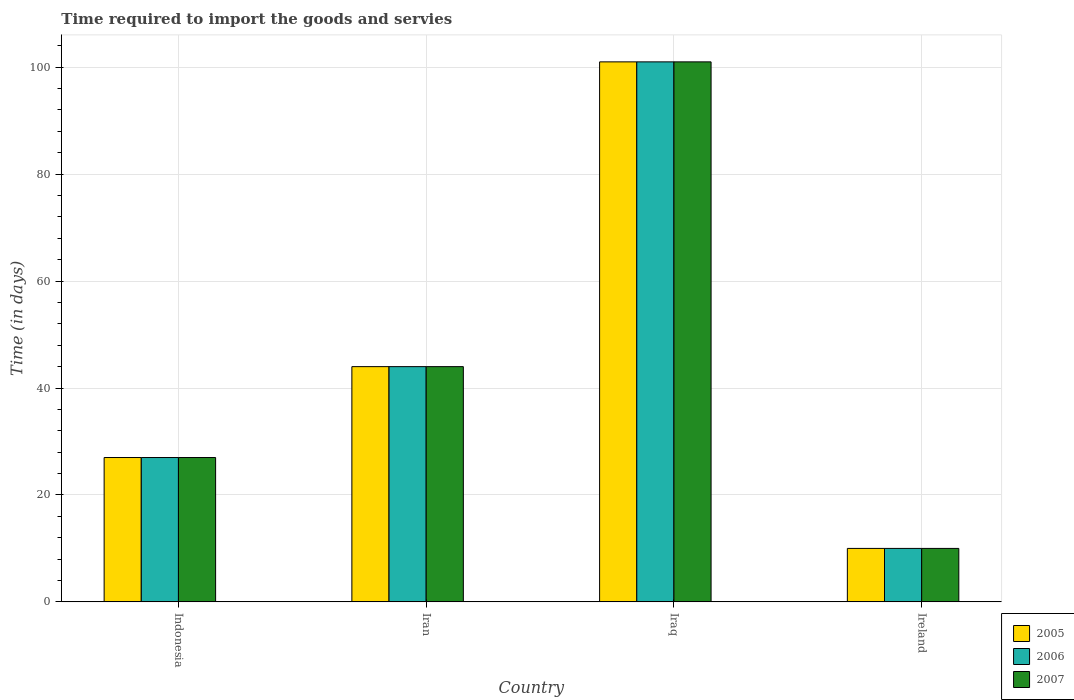How many different coloured bars are there?
Offer a terse response. 3. Are the number of bars per tick equal to the number of legend labels?
Keep it short and to the point. Yes. Are the number of bars on each tick of the X-axis equal?
Give a very brief answer. Yes. How many bars are there on the 3rd tick from the left?
Ensure brevity in your answer.  3. How many bars are there on the 4th tick from the right?
Provide a short and direct response. 3. What is the label of the 4th group of bars from the left?
Ensure brevity in your answer.  Ireland. What is the number of days required to import the goods and services in 2006 in Indonesia?
Your answer should be compact. 27. Across all countries, what is the maximum number of days required to import the goods and services in 2005?
Keep it short and to the point. 101. Across all countries, what is the minimum number of days required to import the goods and services in 2007?
Keep it short and to the point. 10. In which country was the number of days required to import the goods and services in 2006 maximum?
Provide a short and direct response. Iraq. In which country was the number of days required to import the goods and services in 2005 minimum?
Provide a short and direct response. Ireland. What is the total number of days required to import the goods and services in 2007 in the graph?
Your answer should be compact. 182. What is the difference between the number of days required to import the goods and services in 2005 in Iran and that in Iraq?
Make the answer very short. -57. What is the difference between the number of days required to import the goods and services in 2005 in Ireland and the number of days required to import the goods and services in 2006 in Iran?
Provide a succinct answer. -34. What is the average number of days required to import the goods and services in 2006 per country?
Provide a short and direct response. 45.5. Is the number of days required to import the goods and services in 2007 in Iraq less than that in Ireland?
Your response must be concise. No. What is the difference between the highest and the lowest number of days required to import the goods and services in 2005?
Your answer should be compact. 91. In how many countries, is the number of days required to import the goods and services in 2005 greater than the average number of days required to import the goods and services in 2005 taken over all countries?
Make the answer very short. 1. What does the 1st bar from the left in Iran represents?
Your response must be concise. 2005. What does the 2nd bar from the right in Iraq represents?
Offer a terse response. 2006. How many bars are there?
Provide a succinct answer. 12. Are all the bars in the graph horizontal?
Keep it short and to the point. No. How many countries are there in the graph?
Your response must be concise. 4. What is the difference between two consecutive major ticks on the Y-axis?
Your answer should be very brief. 20. Are the values on the major ticks of Y-axis written in scientific E-notation?
Keep it short and to the point. No. Does the graph contain any zero values?
Ensure brevity in your answer.  No. Where does the legend appear in the graph?
Ensure brevity in your answer.  Bottom right. How many legend labels are there?
Provide a succinct answer. 3. How are the legend labels stacked?
Make the answer very short. Vertical. What is the title of the graph?
Provide a succinct answer. Time required to import the goods and servies. What is the label or title of the Y-axis?
Your response must be concise. Time (in days). What is the Time (in days) of 2007 in Indonesia?
Your response must be concise. 27. What is the Time (in days) in 2007 in Iran?
Ensure brevity in your answer.  44. What is the Time (in days) of 2005 in Iraq?
Offer a very short reply. 101. What is the Time (in days) of 2006 in Iraq?
Your answer should be compact. 101. What is the Time (in days) in 2007 in Iraq?
Your answer should be very brief. 101. What is the Time (in days) in 2006 in Ireland?
Your answer should be compact. 10. Across all countries, what is the maximum Time (in days) of 2005?
Offer a terse response. 101. Across all countries, what is the maximum Time (in days) of 2006?
Provide a short and direct response. 101. Across all countries, what is the maximum Time (in days) in 2007?
Give a very brief answer. 101. Across all countries, what is the minimum Time (in days) of 2006?
Ensure brevity in your answer.  10. What is the total Time (in days) in 2005 in the graph?
Provide a short and direct response. 182. What is the total Time (in days) in 2006 in the graph?
Offer a very short reply. 182. What is the total Time (in days) of 2007 in the graph?
Offer a terse response. 182. What is the difference between the Time (in days) of 2006 in Indonesia and that in Iran?
Your answer should be very brief. -17. What is the difference between the Time (in days) in 2005 in Indonesia and that in Iraq?
Make the answer very short. -74. What is the difference between the Time (in days) of 2006 in Indonesia and that in Iraq?
Provide a short and direct response. -74. What is the difference between the Time (in days) in 2007 in Indonesia and that in Iraq?
Your response must be concise. -74. What is the difference between the Time (in days) of 2006 in Indonesia and that in Ireland?
Provide a short and direct response. 17. What is the difference between the Time (in days) in 2007 in Indonesia and that in Ireland?
Provide a short and direct response. 17. What is the difference between the Time (in days) in 2005 in Iran and that in Iraq?
Your answer should be very brief. -57. What is the difference between the Time (in days) in 2006 in Iran and that in Iraq?
Offer a terse response. -57. What is the difference between the Time (in days) in 2007 in Iran and that in Iraq?
Give a very brief answer. -57. What is the difference between the Time (in days) of 2005 in Iraq and that in Ireland?
Ensure brevity in your answer.  91. What is the difference between the Time (in days) in 2006 in Iraq and that in Ireland?
Provide a short and direct response. 91. What is the difference between the Time (in days) in 2007 in Iraq and that in Ireland?
Provide a short and direct response. 91. What is the difference between the Time (in days) of 2005 in Indonesia and the Time (in days) of 2006 in Iran?
Provide a short and direct response. -17. What is the difference between the Time (in days) in 2005 in Indonesia and the Time (in days) in 2006 in Iraq?
Your answer should be very brief. -74. What is the difference between the Time (in days) in 2005 in Indonesia and the Time (in days) in 2007 in Iraq?
Offer a terse response. -74. What is the difference between the Time (in days) in 2006 in Indonesia and the Time (in days) in 2007 in Iraq?
Make the answer very short. -74. What is the difference between the Time (in days) in 2006 in Indonesia and the Time (in days) in 2007 in Ireland?
Keep it short and to the point. 17. What is the difference between the Time (in days) of 2005 in Iran and the Time (in days) of 2006 in Iraq?
Provide a succinct answer. -57. What is the difference between the Time (in days) of 2005 in Iran and the Time (in days) of 2007 in Iraq?
Offer a terse response. -57. What is the difference between the Time (in days) in 2006 in Iran and the Time (in days) in 2007 in Iraq?
Offer a very short reply. -57. What is the difference between the Time (in days) in 2005 in Iran and the Time (in days) in 2007 in Ireland?
Make the answer very short. 34. What is the difference between the Time (in days) in 2005 in Iraq and the Time (in days) in 2006 in Ireland?
Ensure brevity in your answer.  91. What is the difference between the Time (in days) of 2005 in Iraq and the Time (in days) of 2007 in Ireland?
Make the answer very short. 91. What is the difference between the Time (in days) of 2006 in Iraq and the Time (in days) of 2007 in Ireland?
Ensure brevity in your answer.  91. What is the average Time (in days) of 2005 per country?
Provide a short and direct response. 45.5. What is the average Time (in days) of 2006 per country?
Your answer should be very brief. 45.5. What is the average Time (in days) in 2007 per country?
Give a very brief answer. 45.5. What is the difference between the Time (in days) in 2005 and Time (in days) in 2006 in Indonesia?
Your answer should be very brief. 0. What is the difference between the Time (in days) of 2005 and Time (in days) of 2007 in Indonesia?
Give a very brief answer. 0. What is the difference between the Time (in days) of 2005 and Time (in days) of 2007 in Iran?
Keep it short and to the point. 0. What is the difference between the Time (in days) of 2006 and Time (in days) of 2007 in Iran?
Provide a short and direct response. 0. What is the difference between the Time (in days) in 2005 and Time (in days) in 2006 in Iraq?
Give a very brief answer. 0. What is the ratio of the Time (in days) in 2005 in Indonesia to that in Iran?
Provide a short and direct response. 0.61. What is the ratio of the Time (in days) of 2006 in Indonesia to that in Iran?
Provide a short and direct response. 0.61. What is the ratio of the Time (in days) of 2007 in Indonesia to that in Iran?
Provide a succinct answer. 0.61. What is the ratio of the Time (in days) in 2005 in Indonesia to that in Iraq?
Keep it short and to the point. 0.27. What is the ratio of the Time (in days) of 2006 in Indonesia to that in Iraq?
Your answer should be very brief. 0.27. What is the ratio of the Time (in days) in 2007 in Indonesia to that in Iraq?
Ensure brevity in your answer.  0.27. What is the ratio of the Time (in days) of 2005 in Indonesia to that in Ireland?
Your response must be concise. 2.7. What is the ratio of the Time (in days) of 2005 in Iran to that in Iraq?
Keep it short and to the point. 0.44. What is the ratio of the Time (in days) in 2006 in Iran to that in Iraq?
Make the answer very short. 0.44. What is the ratio of the Time (in days) in 2007 in Iran to that in Iraq?
Make the answer very short. 0.44. What is the ratio of the Time (in days) of 2005 in Iran to that in Ireland?
Your response must be concise. 4.4. What is the ratio of the Time (in days) in 2006 in Iran to that in Ireland?
Your answer should be compact. 4.4. What is the ratio of the Time (in days) of 2007 in Iran to that in Ireland?
Offer a terse response. 4.4. What is the ratio of the Time (in days) in 2005 in Iraq to that in Ireland?
Give a very brief answer. 10.1. What is the ratio of the Time (in days) in 2007 in Iraq to that in Ireland?
Your answer should be compact. 10.1. What is the difference between the highest and the lowest Time (in days) of 2005?
Make the answer very short. 91. What is the difference between the highest and the lowest Time (in days) of 2006?
Provide a short and direct response. 91. What is the difference between the highest and the lowest Time (in days) in 2007?
Keep it short and to the point. 91. 